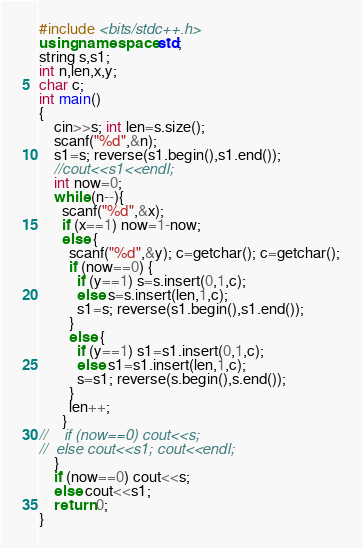Convert code to text. <code><loc_0><loc_0><loc_500><loc_500><_C++_>#include <bits/stdc++.h>
using namespace std;
string s,s1;
int n,len,x,y;
char c;
int main()
{
	cin>>s; int len=s.size(); 
	scanf("%d",&n);
	s1=s; reverse(s1.begin(),s1.end());
	//cout<<s1<<endl;
	int now=0;
	while (n--){
	  scanf("%d",&x);
	  if (x==1) now=1-now;
	  else {
	  	scanf("%d",&y); c=getchar(); c=getchar();
	    if (now==0) {
		  if (y==1) s=s.insert(0,1,c);
		  else s=s.insert(len,1,c);
		  s1=s; reverse(s1.begin(),s1.end());
	    }
	    else {
	      if (y==1) s1=s1.insert(0,1,c);
		  else s1=s1.insert(len,1,c);
		  s=s1; reverse(s.begin(),s.end());
	    }
	    len++;
	  }
//	  if (now==0) cout<<s;
//	else cout<<s1; cout<<endl;
	}
	if (now==0) cout<<s;
	else cout<<s1;
	return 0;
}</code> 